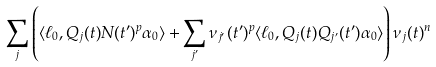Convert formula to latex. <formula><loc_0><loc_0><loc_500><loc_500>\sum _ { j } \left ( \langle \ell _ { 0 } , Q _ { j } ( t ) N ( t ^ { \prime } ) ^ { p } \alpha _ { 0 } \rangle + \sum _ { j ^ { \prime } } \nu _ { j ^ { \prime } } ( t ^ { \prime } ) ^ { p } \langle \ell _ { 0 } , Q _ { j } ( t ) Q _ { j ^ { \prime } } ( t ^ { \prime } ) \alpha _ { 0 } \rangle \right ) \nu _ { j } ( t ) ^ { n }</formula> 